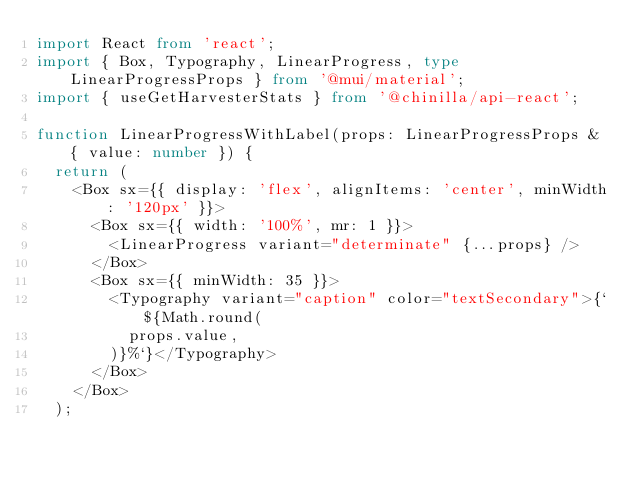<code> <loc_0><loc_0><loc_500><loc_500><_TypeScript_>import React from 'react';
import { Box, Typography, LinearProgress, type LinearProgressProps } from '@mui/material';
import { useGetHarvesterStats } from '@chinilla/api-react';

function LinearProgressWithLabel(props: LinearProgressProps & { value: number }) {
  return (
    <Box sx={{ display: 'flex', alignItems: 'center', minWidth: '120px' }}>
      <Box sx={{ width: '100%', mr: 1 }}>
        <LinearProgress variant="determinate" {...props} />
      </Box>
      <Box sx={{ minWidth: 35 }}>
        <Typography variant="caption" color="textSecondary">{`${Math.round(
          props.value,
        )}%`}</Typography>
      </Box>
    </Box>
  );</code> 